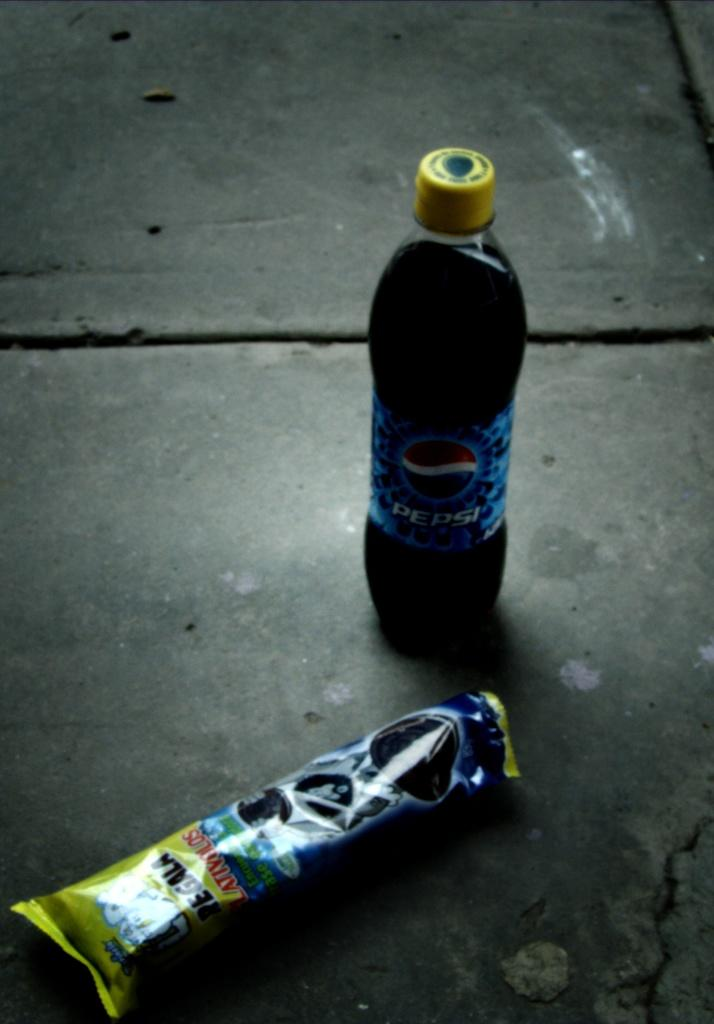What is on the floor in the image? There is a bottle of coke and a chocolate wrapper on the floor. Can you describe the bottle on the floor? The bottle on the floor is a bottle of coke. What else is on the floor besides the bottle? There is also a chocolate wrapper on the floor. What type of jewel is on the floor in the image? There is no jewel present on the floor in the image. 